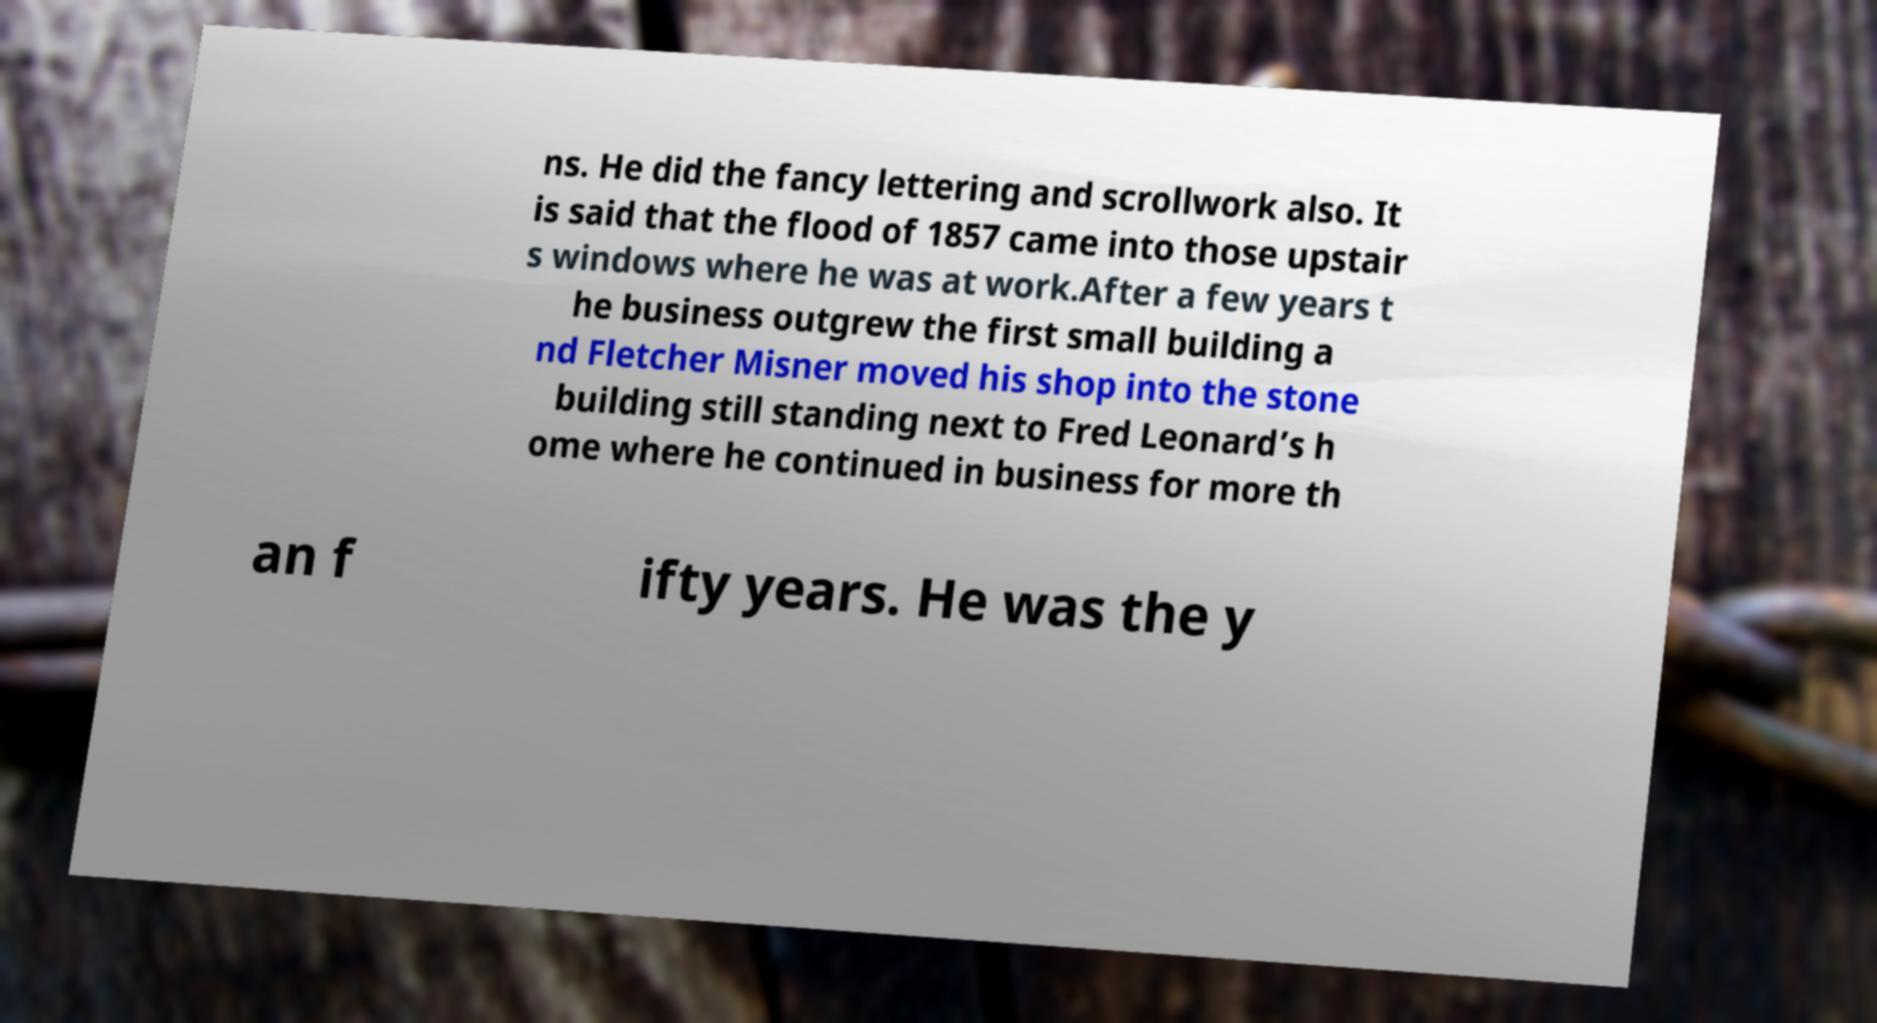Please read and relay the text visible in this image. What does it say? ns. He did the fancy lettering and scrollwork also. It is said that the flood of 1857 came into those upstair s windows where he was at work.After a few years t he business outgrew the first small building a nd Fletcher Misner moved his shop into the stone building still standing next to Fred Leonard’s h ome where he continued in business for more th an f ifty years. He was the y 